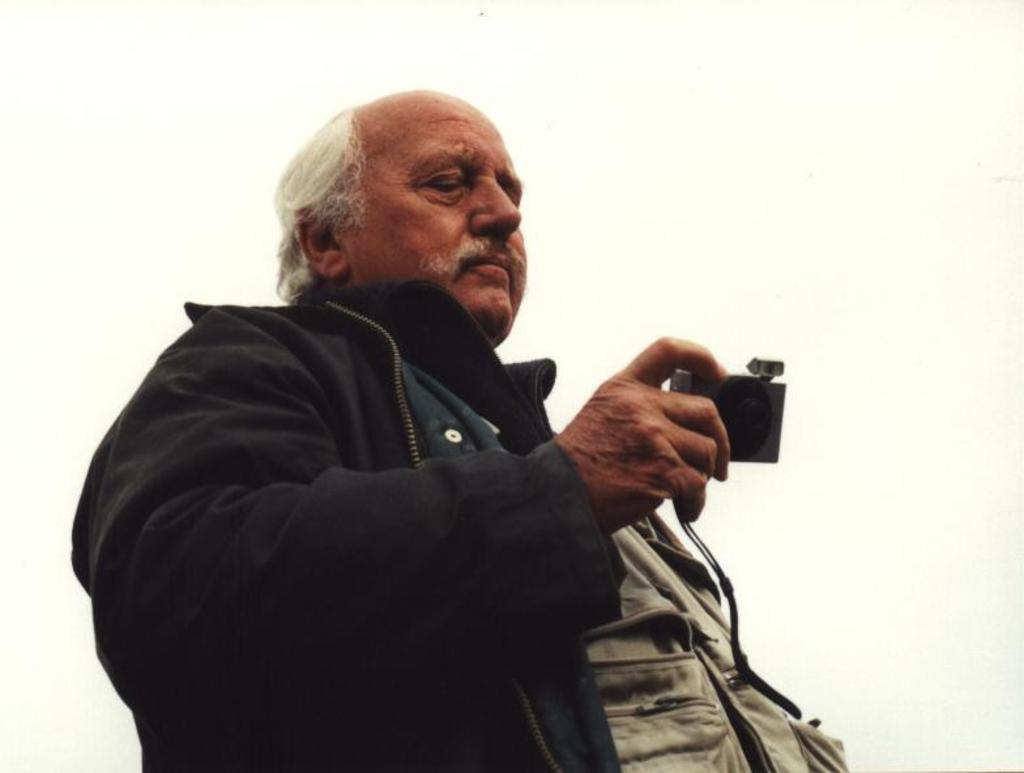Please provide a concise description of this image. This image consists of an old man. He is holding a camera in his hand. He is wearing black color jacket. 